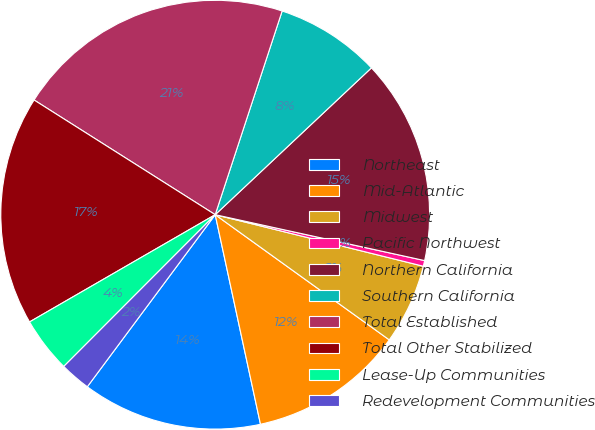Convert chart to OTSL. <chart><loc_0><loc_0><loc_500><loc_500><pie_chart><fcel>Northeast<fcel>Mid-Atlantic<fcel>Midwest<fcel>Pacific Northwest<fcel>Northern California<fcel>Southern California<fcel>Total Established<fcel>Total Other Stabilized<fcel>Lease-Up Communities<fcel>Redevelopment Communities<nl><fcel>13.56%<fcel>11.69%<fcel>6.06%<fcel>0.43%<fcel>15.44%<fcel>7.94%<fcel>21.07%<fcel>17.32%<fcel>4.18%<fcel>2.31%<nl></chart> 